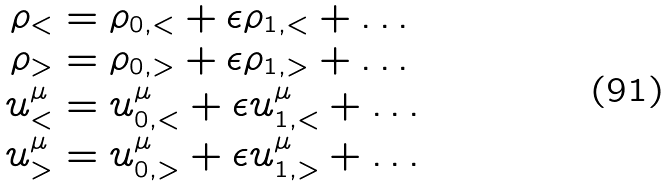Convert formula to latex. <formula><loc_0><loc_0><loc_500><loc_500>\rho _ { < } & = \rho _ { 0 , < } + \epsilon \rho _ { 1 , < } + \dots \\ \rho _ { > } & = \rho _ { 0 , > } + \epsilon \rho _ { 1 , > } + \dots \\ u ^ { \mu } _ { < } & = u _ { 0 , < } ^ { \mu } + \epsilon u _ { 1 , < } ^ { \mu } + \dots \\ u ^ { \mu } _ { > } & = u _ { 0 , > } ^ { \mu } + \epsilon u _ { 1 , > } ^ { \mu } + \dots</formula> 